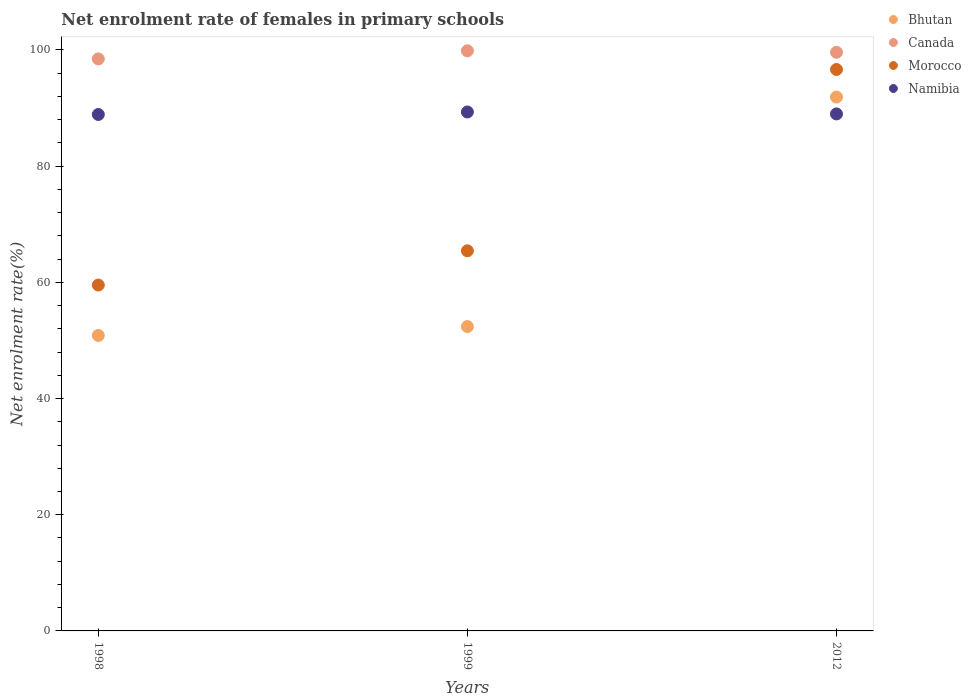What is the net enrolment rate of females in primary schools in Canada in 1998?
Offer a terse response. 98.46. Across all years, what is the maximum net enrolment rate of females in primary schools in Morocco?
Your response must be concise. 96.64. Across all years, what is the minimum net enrolment rate of females in primary schools in Canada?
Offer a very short reply. 98.46. In which year was the net enrolment rate of females in primary schools in Morocco maximum?
Provide a succinct answer. 2012. In which year was the net enrolment rate of females in primary schools in Canada minimum?
Provide a succinct answer. 1998. What is the total net enrolment rate of females in primary schools in Morocco in the graph?
Ensure brevity in your answer.  221.6. What is the difference between the net enrolment rate of females in primary schools in Namibia in 1998 and that in 2012?
Make the answer very short. -0.09. What is the difference between the net enrolment rate of females in primary schools in Canada in 1998 and the net enrolment rate of females in primary schools in Bhutan in 2012?
Give a very brief answer. 6.57. What is the average net enrolment rate of females in primary schools in Bhutan per year?
Make the answer very short. 65.04. In the year 2012, what is the difference between the net enrolment rate of females in primary schools in Namibia and net enrolment rate of females in primary schools in Bhutan?
Your response must be concise. -2.9. What is the ratio of the net enrolment rate of females in primary schools in Canada in 1999 to that in 2012?
Your answer should be very brief. 1. Is the net enrolment rate of females in primary schools in Namibia in 1998 less than that in 2012?
Provide a succinct answer. Yes. What is the difference between the highest and the second highest net enrolment rate of females in primary schools in Canada?
Keep it short and to the point. 0.26. What is the difference between the highest and the lowest net enrolment rate of females in primary schools in Canada?
Make the answer very short. 1.39. In how many years, is the net enrolment rate of females in primary schools in Namibia greater than the average net enrolment rate of females in primary schools in Namibia taken over all years?
Your response must be concise. 1. Does the net enrolment rate of females in primary schools in Namibia monotonically increase over the years?
Provide a short and direct response. No. Is the net enrolment rate of females in primary schools in Morocco strictly greater than the net enrolment rate of females in primary schools in Canada over the years?
Keep it short and to the point. No. How many dotlines are there?
Your answer should be very brief. 4. How many years are there in the graph?
Keep it short and to the point. 3. Are the values on the major ticks of Y-axis written in scientific E-notation?
Provide a succinct answer. No. Does the graph contain grids?
Make the answer very short. No. Where does the legend appear in the graph?
Offer a terse response. Top right. What is the title of the graph?
Your answer should be compact. Net enrolment rate of females in primary schools. Does "Congo (Republic)" appear as one of the legend labels in the graph?
Provide a short and direct response. No. What is the label or title of the X-axis?
Offer a terse response. Years. What is the label or title of the Y-axis?
Your answer should be very brief. Net enrolment rate(%). What is the Net enrolment rate(%) of Bhutan in 1998?
Your response must be concise. 50.86. What is the Net enrolment rate(%) in Canada in 1998?
Offer a terse response. 98.46. What is the Net enrolment rate(%) of Morocco in 1998?
Provide a short and direct response. 59.53. What is the Net enrolment rate(%) of Namibia in 1998?
Your answer should be compact. 88.89. What is the Net enrolment rate(%) of Bhutan in 1999?
Your answer should be compact. 52.39. What is the Net enrolment rate(%) in Canada in 1999?
Ensure brevity in your answer.  99.85. What is the Net enrolment rate(%) in Morocco in 1999?
Provide a succinct answer. 65.43. What is the Net enrolment rate(%) of Namibia in 1999?
Your answer should be compact. 89.32. What is the Net enrolment rate(%) of Bhutan in 2012?
Your response must be concise. 91.89. What is the Net enrolment rate(%) of Canada in 2012?
Your answer should be very brief. 99.59. What is the Net enrolment rate(%) of Morocco in 2012?
Your response must be concise. 96.64. What is the Net enrolment rate(%) of Namibia in 2012?
Ensure brevity in your answer.  88.99. Across all years, what is the maximum Net enrolment rate(%) in Bhutan?
Your response must be concise. 91.89. Across all years, what is the maximum Net enrolment rate(%) of Canada?
Give a very brief answer. 99.85. Across all years, what is the maximum Net enrolment rate(%) in Morocco?
Offer a terse response. 96.64. Across all years, what is the maximum Net enrolment rate(%) of Namibia?
Your answer should be compact. 89.32. Across all years, what is the minimum Net enrolment rate(%) of Bhutan?
Your response must be concise. 50.86. Across all years, what is the minimum Net enrolment rate(%) in Canada?
Your response must be concise. 98.46. Across all years, what is the minimum Net enrolment rate(%) of Morocco?
Your answer should be compact. 59.53. Across all years, what is the minimum Net enrolment rate(%) of Namibia?
Provide a short and direct response. 88.89. What is the total Net enrolment rate(%) in Bhutan in the graph?
Provide a succinct answer. 195.13. What is the total Net enrolment rate(%) in Canada in the graph?
Ensure brevity in your answer.  297.9. What is the total Net enrolment rate(%) of Morocco in the graph?
Offer a very short reply. 221.6. What is the total Net enrolment rate(%) in Namibia in the graph?
Your answer should be compact. 267.2. What is the difference between the Net enrolment rate(%) of Bhutan in 1998 and that in 1999?
Offer a terse response. -1.53. What is the difference between the Net enrolment rate(%) in Canada in 1998 and that in 1999?
Your answer should be very brief. -1.39. What is the difference between the Net enrolment rate(%) in Morocco in 1998 and that in 1999?
Your answer should be very brief. -5.89. What is the difference between the Net enrolment rate(%) of Namibia in 1998 and that in 1999?
Ensure brevity in your answer.  -0.43. What is the difference between the Net enrolment rate(%) of Bhutan in 1998 and that in 2012?
Make the answer very short. -41.03. What is the difference between the Net enrolment rate(%) of Canada in 1998 and that in 2012?
Your answer should be compact. -1.14. What is the difference between the Net enrolment rate(%) in Morocco in 1998 and that in 2012?
Give a very brief answer. -37.1. What is the difference between the Net enrolment rate(%) in Namibia in 1998 and that in 2012?
Your response must be concise. -0.09. What is the difference between the Net enrolment rate(%) in Bhutan in 1999 and that in 2012?
Make the answer very short. -39.51. What is the difference between the Net enrolment rate(%) in Canada in 1999 and that in 2012?
Provide a short and direct response. 0.26. What is the difference between the Net enrolment rate(%) in Morocco in 1999 and that in 2012?
Your answer should be compact. -31.21. What is the difference between the Net enrolment rate(%) of Namibia in 1999 and that in 2012?
Your answer should be compact. 0.33. What is the difference between the Net enrolment rate(%) of Bhutan in 1998 and the Net enrolment rate(%) of Canada in 1999?
Provide a short and direct response. -49. What is the difference between the Net enrolment rate(%) in Bhutan in 1998 and the Net enrolment rate(%) in Morocco in 1999?
Provide a short and direct response. -14.57. What is the difference between the Net enrolment rate(%) of Bhutan in 1998 and the Net enrolment rate(%) of Namibia in 1999?
Your answer should be very brief. -38.47. What is the difference between the Net enrolment rate(%) of Canada in 1998 and the Net enrolment rate(%) of Morocco in 1999?
Provide a short and direct response. 33.03. What is the difference between the Net enrolment rate(%) of Canada in 1998 and the Net enrolment rate(%) of Namibia in 1999?
Provide a succinct answer. 9.14. What is the difference between the Net enrolment rate(%) of Morocco in 1998 and the Net enrolment rate(%) of Namibia in 1999?
Your response must be concise. -29.79. What is the difference between the Net enrolment rate(%) in Bhutan in 1998 and the Net enrolment rate(%) in Canada in 2012?
Your answer should be very brief. -48.74. What is the difference between the Net enrolment rate(%) in Bhutan in 1998 and the Net enrolment rate(%) in Morocco in 2012?
Offer a very short reply. -45.78. What is the difference between the Net enrolment rate(%) of Bhutan in 1998 and the Net enrolment rate(%) of Namibia in 2012?
Your answer should be very brief. -38.13. What is the difference between the Net enrolment rate(%) of Canada in 1998 and the Net enrolment rate(%) of Morocco in 2012?
Offer a very short reply. 1.82. What is the difference between the Net enrolment rate(%) in Canada in 1998 and the Net enrolment rate(%) in Namibia in 2012?
Offer a terse response. 9.47. What is the difference between the Net enrolment rate(%) in Morocco in 1998 and the Net enrolment rate(%) in Namibia in 2012?
Ensure brevity in your answer.  -29.45. What is the difference between the Net enrolment rate(%) in Bhutan in 1999 and the Net enrolment rate(%) in Canada in 2012?
Your answer should be very brief. -47.21. What is the difference between the Net enrolment rate(%) in Bhutan in 1999 and the Net enrolment rate(%) in Morocco in 2012?
Your answer should be compact. -44.25. What is the difference between the Net enrolment rate(%) of Bhutan in 1999 and the Net enrolment rate(%) of Namibia in 2012?
Make the answer very short. -36.6. What is the difference between the Net enrolment rate(%) of Canada in 1999 and the Net enrolment rate(%) of Morocco in 2012?
Offer a very short reply. 3.21. What is the difference between the Net enrolment rate(%) in Canada in 1999 and the Net enrolment rate(%) in Namibia in 2012?
Offer a terse response. 10.86. What is the difference between the Net enrolment rate(%) of Morocco in 1999 and the Net enrolment rate(%) of Namibia in 2012?
Make the answer very short. -23.56. What is the average Net enrolment rate(%) in Bhutan per year?
Your answer should be very brief. 65.04. What is the average Net enrolment rate(%) of Canada per year?
Give a very brief answer. 99.3. What is the average Net enrolment rate(%) of Morocco per year?
Make the answer very short. 73.87. What is the average Net enrolment rate(%) in Namibia per year?
Provide a short and direct response. 89.07. In the year 1998, what is the difference between the Net enrolment rate(%) in Bhutan and Net enrolment rate(%) in Canada?
Your answer should be very brief. -47.6. In the year 1998, what is the difference between the Net enrolment rate(%) of Bhutan and Net enrolment rate(%) of Morocco?
Give a very brief answer. -8.68. In the year 1998, what is the difference between the Net enrolment rate(%) of Bhutan and Net enrolment rate(%) of Namibia?
Ensure brevity in your answer.  -38.04. In the year 1998, what is the difference between the Net enrolment rate(%) of Canada and Net enrolment rate(%) of Morocco?
Offer a very short reply. 38.92. In the year 1998, what is the difference between the Net enrolment rate(%) in Canada and Net enrolment rate(%) in Namibia?
Ensure brevity in your answer.  9.57. In the year 1998, what is the difference between the Net enrolment rate(%) of Morocco and Net enrolment rate(%) of Namibia?
Your response must be concise. -29.36. In the year 1999, what is the difference between the Net enrolment rate(%) of Bhutan and Net enrolment rate(%) of Canada?
Give a very brief answer. -47.47. In the year 1999, what is the difference between the Net enrolment rate(%) in Bhutan and Net enrolment rate(%) in Morocco?
Offer a very short reply. -13.04. In the year 1999, what is the difference between the Net enrolment rate(%) in Bhutan and Net enrolment rate(%) in Namibia?
Your response must be concise. -36.94. In the year 1999, what is the difference between the Net enrolment rate(%) in Canada and Net enrolment rate(%) in Morocco?
Provide a short and direct response. 34.42. In the year 1999, what is the difference between the Net enrolment rate(%) of Canada and Net enrolment rate(%) of Namibia?
Offer a very short reply. 10.53. In the year 1999, what is the difference between the Net enrolment rate(%) of Morocco and Net enrolment rate(%) of Namibia?
Your answer should be very brief. -23.89. In the year 2012, what is the difference between the Net enrolment rate(%) of Bhutan and Net enrolment rate(%) of Canada?
Your response must be concise. -7.7. In the year 2012, what is the difference between the Net enrolment rate(%) in Bhutan and Net enrolment rate(%) in Morocco?
Provide a short and direct response. -4.75. In the year 2012, what is the difference between the Net enrolment rate(%) of Bhutan and Net enrolment rate(%) of Namibia?
Your answer should be compact. 2.9. In the year 2012, what is the difference between the Net enrolment rate(%) of Canada and Net enrolment rate(%) of Morocco?
Ensure brevity in your answer.  2.96. In the year 2012, what is the difference between the Net enrolment rate(%) of Canada and Net enrolment rate(%) of Namibia?
Your answer should be compact. 10.61. In the year 2012, what is the difference between the Net enrolment rate(%) in Morocco and Net enrolment rate(%) in Namibia?
Make the answer very short. 7.65. What is the ratio of the Net enrolment rate(%) in Bhutan in 1998 to that in 1999?
Offer a very short reply. 0.97. What is the ratio of the Net enrolment rate(%) in Morocco in 1998 to that in 1999?
Your response must be concise. 0.91. What is the ratio of the Net enrolment rate(%) of Bhutan in 1998 to that in 2012?
Provide a short and direct response. 0.55. What is the ratio of the Net enrolment rate(%) in Canada in 1998 to that in 2012?
Keep it short and to the point. 0.99. What is the ratio of the Net enrolment rate(%) of Morocco in 1998 to that in 2012?
Your answer should be compact. 0.62. What is the ratio of the Net enrolment rate(%) in Bhutan in 1999 to that in 2012?
Provide a succinct answer. 0.57. What is the ratio of the Net enrolment rate(%) of Morocco in 1999 to that in 2012?
Keep it short and to the point. 0.68. What is the ratio of the Net enrolment rate(%) in Namibia in 1999 to that in 2012?
Ensure brevity in your answer.  1. What is the difference between the highest and the second highest Net enrolment rate(%) of Bhutan?
Keep it short and to the point. 39.51. What is the difference between the highest and the second highest Net enrolment rate(%) of Canada?
Ensure brevity in your answer.  0.26. What is the difference between the highest and the second highest Net enrolment rate(%) of Morocco?
Your response must be concise. 31.21. What is the difference between the highest and the second highest Net enrolment rate(%) in Namibia?
Make the answer very short. 0.33. What is the difference between the highest and the lowest Net enrolment rate(%) of Bhutan?
Provide a succinct answer. 41.03. What is the difference between the highest and the lowest Net enrolment rate(%) of Canada?
Give a very brief answer. 1.39. What is the difference between the highest and the lowest Net enrolment rate(%) in Morocco?
Make the answer very short. 37.1. What is the difference between the highest and the lowest Net enrolment rate(%) of Namibia?
Provide a succinct answer. 0.43. 